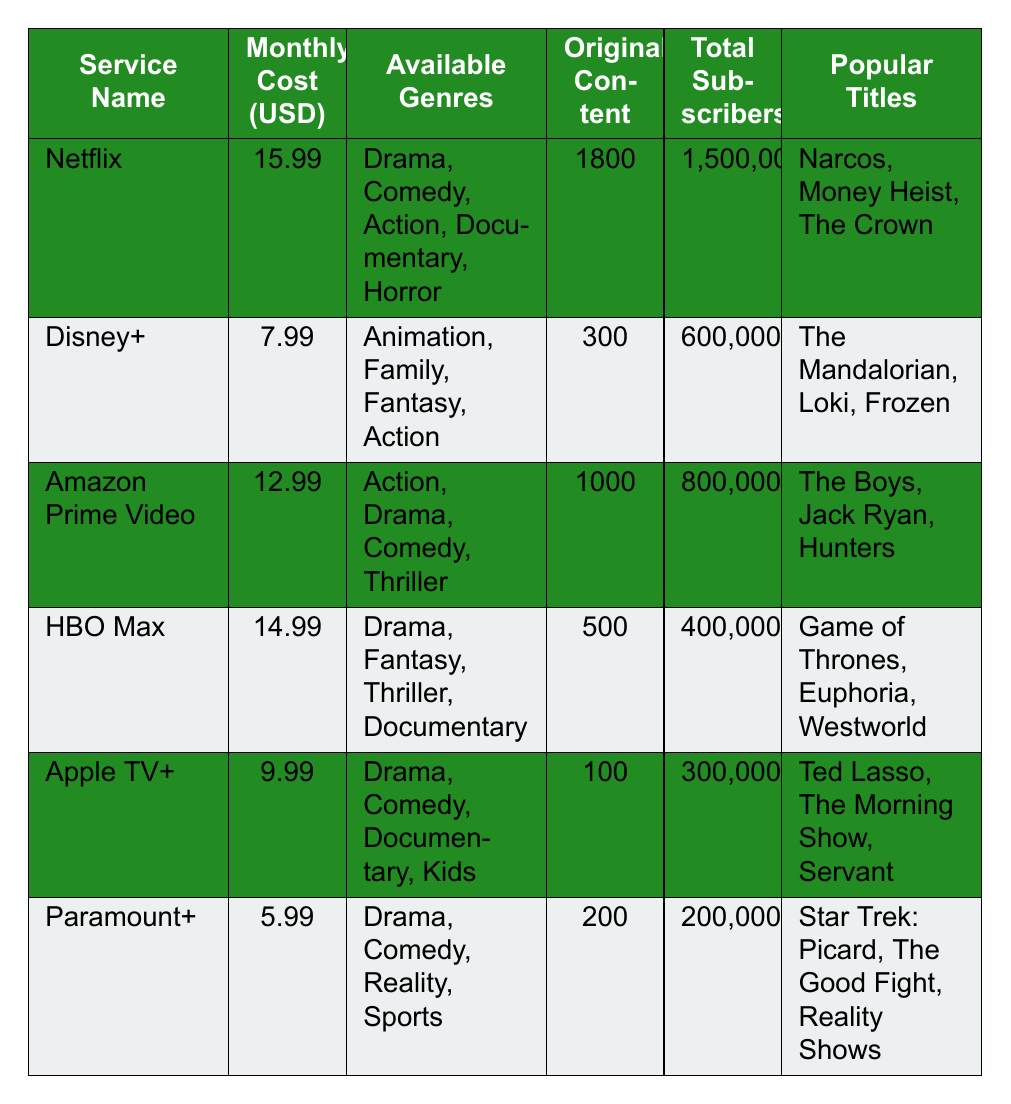What is the monthly cost of Netflix? The table lists the monthly cost for Netflix under the "Monthly Cost (USD)" column, which shows $15.99.
Answer: $15.99 How many total subscribers does Amazon Prime Video have? The total subscriber count for Amazon Prime Video is located in the "Total Subscribers" column and is listed as 800,000.
Answer: 800,000 Which streaming service has the highest number of original content? Comparing the "Original Content" values in the table, Netflix has 1,800, which is the highest.
Answer: Netflix What is the average monthly cost of all the listed streaming services? The monthly costs are $15.99 (Netflix), $7.99 (Disney+), $12.99 (Amazon Prime Video), $14.99 (HBO Max), $9.99 (Apple TV+), and $5.99 (Paramount+). Summing these gives $67.94, and dividing by 6 (the number of services) gives an average of $11.32.
Answer: $11.32 Does Paramount+ have more or fewer total subscribers than HBO Max? Paramount+ has 200,000 subscribers, while HBO Max has 400,000. Since 200,000 is less than 400,000, the answer is fewer.
Answer: Fewer Which streaming service has the most available genres? By examining the "Available Genres" column, Netflix lists 5 genres (Drama, Comedy, Action, Documentary, Horror), which is the highest.
Answer: Netflix If you combine the subscribers of Disney+ and Paramount+, how many subscribers would there be in total? Disney+ has 600,000 subscribers, and Paramount+ has 200,000. Adding these gives 600,000 + 200,000 = 800,000 subscribers in total.
Answer: 800,000 Is there any streaming service that offers original content between 500 and 1000? The table lists HBO Max with 500 and Amazon Prime Video with 1000, so there is no service specifically within that range.
Answer: No What are the popular titles of Apple TV+? The popular titles for Apple TV+ are listed under the "Popular Titles" column as Ted Lasso, The Morning Show, and Servant.
Answer: Ted Lasso, The Morning Show, Servant Which streaming service has the lowest monthly cost? The "Monthly Cost (USD)" column shows that Paramount+ has the lowest cost at $5.99.
Answer: Paramount+ 